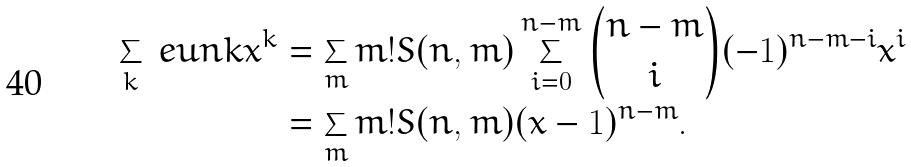<formula> <loc_0><loc_0><loc_500><loc_500>\sum _ { k } \ e u n k x ^ { k } & = \sum _ { m } m ! S ( n , m ) \sum _ { i = 0 } ^ { n - m } \binom { n - m } { i } ( - 1 ) ^ { n - m - i } x ^ { i } \\ & = \sum _ { m } m ! S ( n , m ) ( x - 1 ) ^ { n - m } .</formula> 